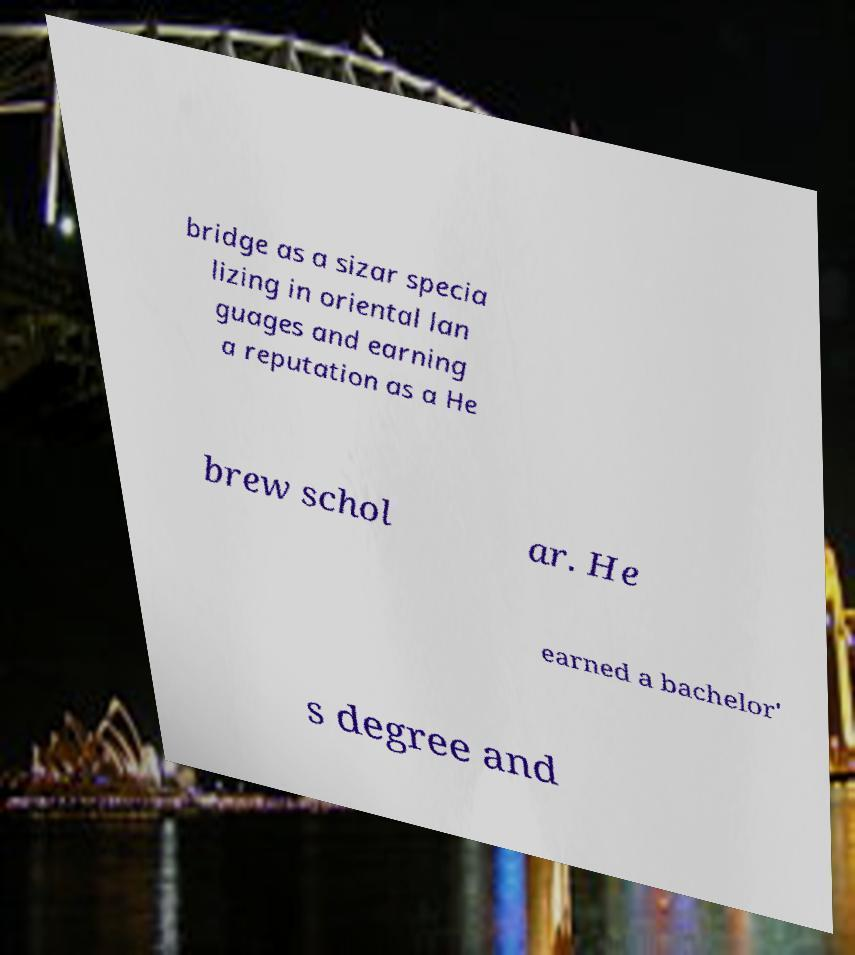Please identify and transcribe the text found in this image. bridge as a sizar specia lizing in oriental lan guages and earning a reputation as a He brew schol ar. He earned a bachelor' s degree and 